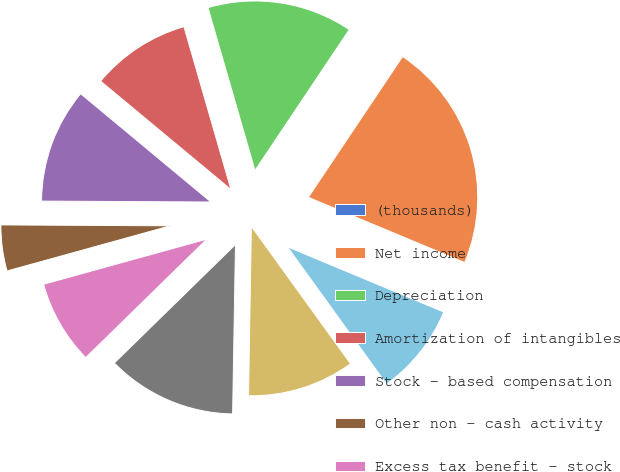<chart> <loc_0><loc_0><loc_500><loc_500><pie_chart><fcel>(thousands)<fcel>Net income<fcel>Depreciation<fcel>Amortization of intangibles<fcel>Stock - based compensation<fcel>Other non - cash activity<fcel>Excess tax benefit - stock<fcel>Deferred income taxes<fcel>Accounts receivable<fcel>Inventories<nl><fcel>0.0%<fcel>21.9%<fcel>13.87%<fcel>9.49%<fcel>10.95%<fcel>4.38%<fcel>8.03%<fcel>12.41%<fcel>10.22%<fcel>8.76%<nl></chart> 